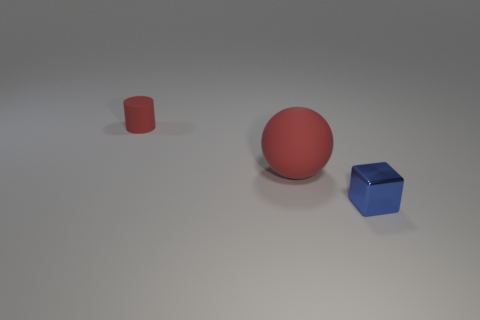Is the tiny object that is to the left of the blue metallic block made of the same material as the sphere?
Keep it short and to the point. Yes. How many spheres are either red matte things or tiny brown rubber things?
Offer a terse response. 1. There is a object that is both in front of the tiny red rubber thing and to the left of the tiny metallic object; what is its shape?
Make the answer very short. Sphere. There is a thing that is in front of the red matte object that is in front of the tiny object to the left of the small blue shiny object; what is its color?
Offer a terse response. Blue. Are there fewer things left of the matte cylinder than blue metal things?
Ensure brevity in your answer.  Yes. There is a matte object in front of the cylinder; does it have the same shape as the thing that is left of the red rubber sphere?
Ensure brevity in your answer.  No. What number of things are small rubber cylinders that are left of the large red sphere or large yellow metallic objects?
Your answer should be compact. 1. What is the material of the large sphere that is the same color as the tiny rubber object?
Ensure brevity in your answer.  Rubber. Are there any objects to the left of the tiny object that is left of the object that is on the right side of the large thing?
Offer a terse response. No. Is the number of red matte cylinders that are to the left of the tiny matte cylinder less than the number of small blue cubes that are to the right of the blue object?
Make the answer very short. No. 